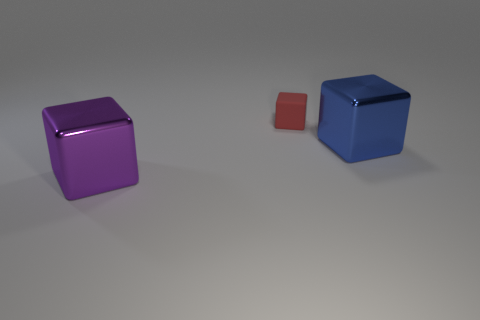What lighting conditions are present in the scene with the cubes? The lighting in the image appears to be diffused, with soft shadows indicating an indirect light source, likely suggesting an indoor setting with either natural light coming from a window or artificial ambient lighting. 